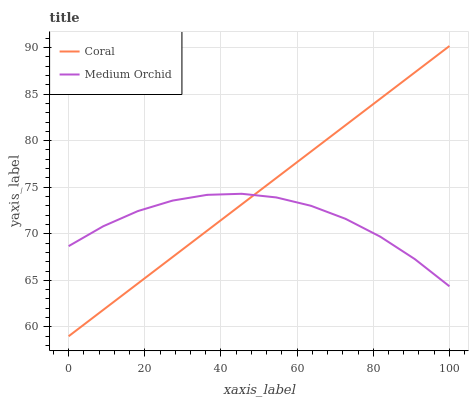Does Medium Orchid have the minimum area under the curve?
Answer yes or no. Yes. Does Coral have the maximum area under the curve?
Answer yes or no. Yes. Does Medium Orchid have the maximum area under the curve?
Answer yes or no. No. Is Coral the smoothest?
Answer yes or no. Yes. Is Medium Orchid the roughest?
Answer yes or no. Yes. Is Medium Orchid the smoothest?
Answer yes or no. No. Does Coral have the lowest value?
Answer yes or no. Yes. Does Medium Orchid have the lowest value?
Answer yes or no. No. Does Coral have the highest value?
Answer yes or no. Yes. Does Medium Orchid have the highest value?
Answer yes or no. No. Does Coral intersect Medium Orchid?
Answer yes or no. Yes. Is Coral less than Medium Orchid?
Answer yes or no. No. Is Coral greater than Medium Orchid?
Answer yes or no. No. 